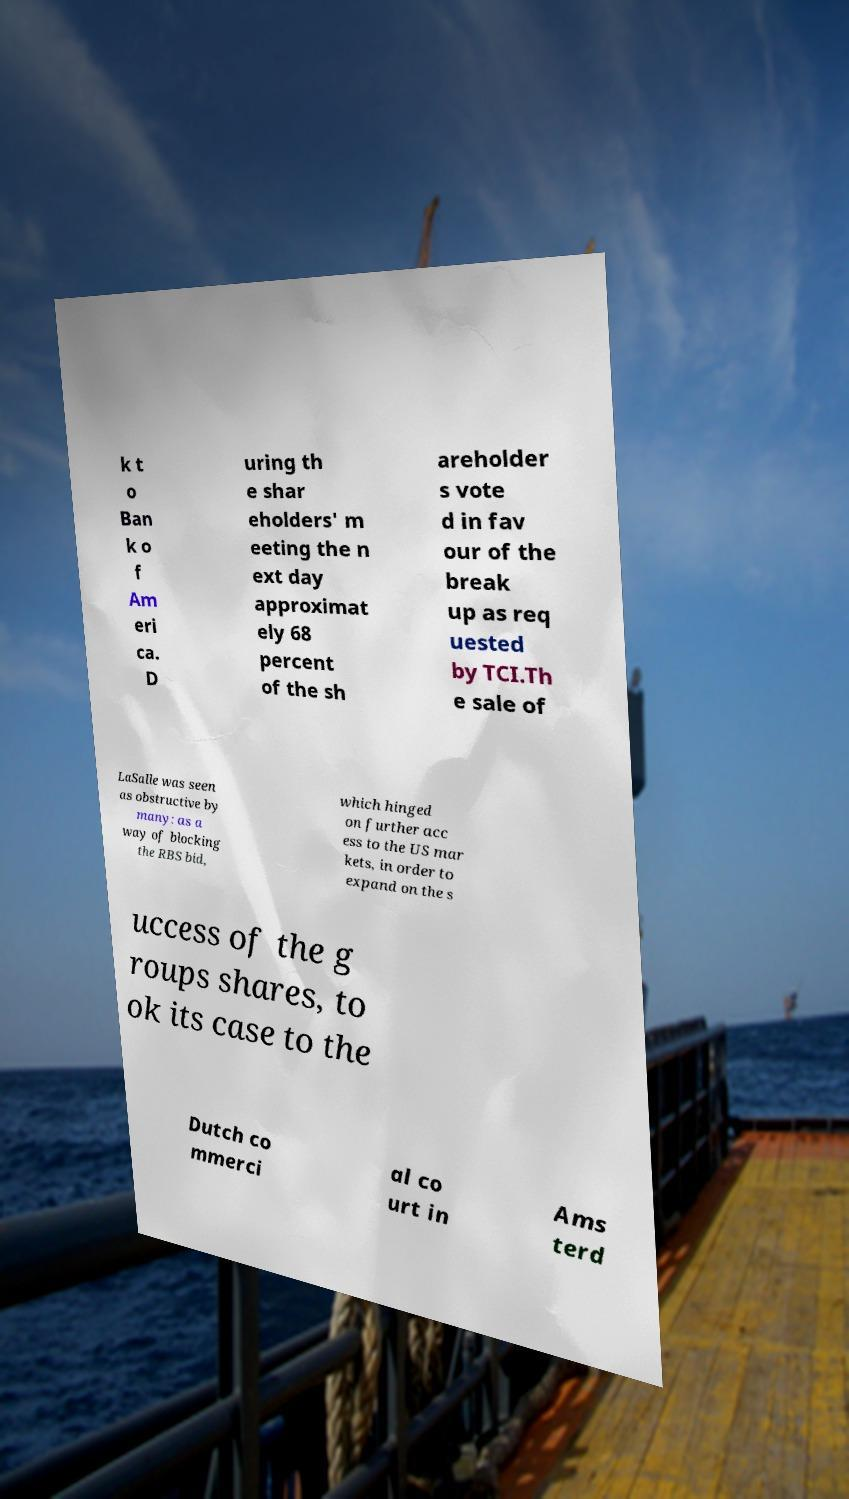Could you assist in decoding the text presented in this image and type it out clearly? k t o Ban k o f Am eri ca. D uring th e shar eholders' m eeting the n ext day approximat ely 68 percent of the sh areholder s vote d in fav our of the break up as req uested by TCI.Th e sale of LaSalle was seen as obstructive by many: as a way of blocking the RBS bid, which hinged on further acc ess to the US mar kets, in order to expand on the s uccess of the g roups shares, to ok its case to the Dutch co mmerci al co urt in Ams terd 